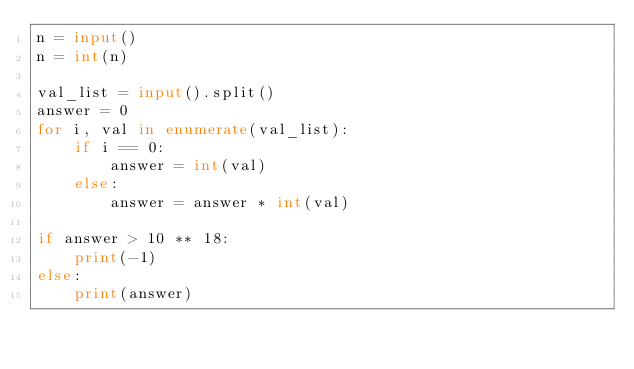<code> <loc_0><loc_0><loc_500><loc_500><_Python_>n = input()
n = int(n)

val_list = input().split()
answer = 0
for i, val in enumerate(val_list):
    if i == 0:
        answer = int(val)
    else:
        answer = answer * int(val)

if answer > 10 ** 18:
    print(-1)
else:
    print(answer)
</code> 